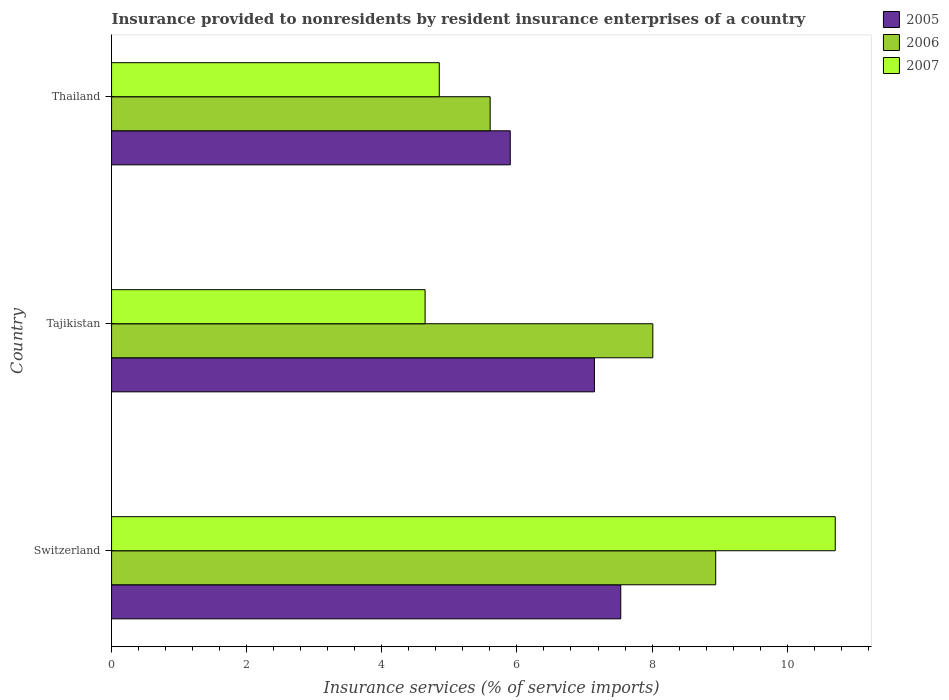Are the number of bars per tick equal to the number of legend labels?
Your answer should be compact. Yes. Are the number of bars on each tick of the Y-axis equal?
Your answer should be compact. Yes. How many bars are there on the 1st tick from the top?
Your answer should be compact. 3. What is the label of the 1st group of bars from the top?
Offer a very short reply. Thailand. What is the insurance provided to nonresidents in 2007 in Switzerland?
Your answer should be compact. 10.71. Across all countries, what is the maximum insurance provided to nonresidents in 2007?
Your answer should be very brief. 10.71. Across all countries, what is the minimum insurance provided to nonresidents in 2005?
Keep it short and to the point. 5.9. In which country was the insurance provided to nonresidents in 2005 maximum?
Your answer should be compact. Switzerland. In which country was the insurance provided to nonresidents in 2007 minimum?
Offer a very short reply. Tajikistan. What is the total insurance provided to nonresidents in 2006 in the graph?
Your answer should be compact. 22.56. What is the difference between the insurance provided to nonresidents in 2005 in Switzerland and that in Tajikistan?
Keep it short and to the point. 0.39. What is the difference between the insurance provided to nonresidents in 2005 in Thailand and the insurance provided to nonresidents in 2006 in Tajikistan?
Your response must be concise. -2.11. What is the average insurance provided to nonresidents in 2005 per country?
Offer a terse response. 6.86. What is the difference between the insurance provided to nonresidents in 2007 and insurance provided to nonresidents in 2006 in Switzerland?
Offer a terse response. 1.77. What is the ratio of the insurance provided to nonresidents in 2006 in Switzerland to that in Tajikistan?
Your answer should be very brief. 1.12. Is the insurance provided to nonresidents in 2005 in Switzerland less than that in Thailand?
Offer a terse response. No. Is the difference between the insurance provided to nonresidents in 2007 in Tajikistan and Thailand greater than the difference between the insurance provided to nonresidents in 2006 in Tajikistan and Thailand?
Provide a short and direct response. No. What is the difference between the highest and the second highest insurance provided to nonresidents in 2007?
Keep it short and to the point. 5.86. What is the difference between the highest and the lowest insurance provided to nonresidents in 2006?
Provide a short and direct response. 3.34. In how many countries, is the insurance provided to nonresidents in 2005 greater than the average insurance provided to nonresidents in 2005 taken over all countries?
Provide a succinct answer. 2. Is it the case that in every country, the sum of the insurance provided to nonresidents in 2005 and insurance provided to nonresidents in 2007 is greater than the insurance provided to nonresidents in 2006?
Your answer should be compact. Yes. Are all the bars in the graph horizontal?
Provide a short and direct response. Yes. How many countries are there in the graph?
Offer a very short reply. 3. Are the values on the major ticks of X-axis written in scientific E-notation?
Your answer should be very brief. No. Does the graph contain grids?
Make the answer very short. No. Where does the legend appear in the graph?
Ensure brevity in your answer.  Top right. How are the legend labels stacked?
Ensure brevity in your answer.  Vertical. What is the title of the graph?
Provide a short and direct response. Insurance provided to nonresidents by resident insurance enterprises of a country. What is the label or title of the X-axis?
Provide a short and direct response. Insurance services (% of service imports). What is the Insurance services (% of service imports) in 2005 in Switzerland?
Your answer should be very brief. 7.54. What is the Insurance services (% of service imports) in 2006 in Switzerland?
Offer a terse response. 8.94. What is the Insurance services (% of service imports) in 2007 in Switzerland?
Ensure brevity in your answer.  10.71. What is the Insurance services (% of service imports) of 2005 in Tajikistan?
Your response must be concise. 7.15. What is the Insurance services (% of service imports) of 2006 in Tajikistan?
Provide a succinct answer. 8.01. What is the Insurance services (% of service imports) of 2007 in Tajikistan?
Offer a terse response. 4.64. What is the Insurance services (% of service imports) in 2005 in Thailand?
Provide a succinct answer. 5.9. What is the Insurance services (% of service imports) of 2006 in Thailand?
Your answer should be very brief. 5.6. What is the Insurance services (% of service imports) in 2007 in Thailand?
Make the answer very short. 4.85. Across all countries, what is the maximum Insurance services (% of service imports) of 2005?
Offer a terse response. 7.54. Across all countries, what is the maximum Insurance services (% of service imports) in 2006?
Your response must be concise. 8.94. Across all countries, what is the maximum Insurance services (% of service imports) in 2007?
Your answer should be compact. 10.71. Across all countries, what is the minimum Insurance services (% of service imports) in 2005?
Ensure brevity in your answer.  5.9. Across all countries, what is the minimum Insurance services (% of service imports) of 2006?
Provide a short and direct response. 5.6. Across all countries, what is the minimum Insurance services (% of service imports) in 2007?
Give a very brief answer. 4.64. What is the total Insurance services (% of service imports) in 2005 in the graph?
Make the answer very short. 20.58. What is the total Insurance services (% of service imports) of 2006 in the graph?
Your answer should be very brief. 22.56. What is the total Insurance services (% of service imports) of 2007 in the graph?
Offer a terse response. 20.2. What is the difference between the Insurance services (% of service imports) of 2005 in Switzerland and that in Tajikistan?
Your answer should be compact. 0.39. What is the difference between the Insurance services (% of service imports) in 2006 in Switzerland and that in Tajikistan?
Offer a very short reply. 0.93. What is the difference between the Insurance services (% of service imports) of 2007 in Switzerland and that in Tajikistan?
Provide a succinct answer. 6.07. What is the difference between the Insurance services (% of service imports) of 2005 in Switzerland and that in Thailand?
Offer a terse response. 1.64. What is the difference between the Insurance services (% of service imports) of 2006 in Switzerland and that in Thailand?
Your answer should be very brief. 3.34. What is the difference between the Insurance services (% of service imports) of 2007 in Switzerland and that in Thailand?
Offer a very short reply. 5.86. What is the difference between the Insurance services (% of service imports) in 2005 in Tajikistan and that in Thailand?
Provide a succinct answer. 1.25. What is the difference between the Insurance services (% of service imports) in 2006 in Tajikistan and that in Thailand?
Offer a terse response. 2.41. What is the difference between the Insurance services (% of service imports) in 2007 in Tajikistan and that in Thailand?
Offer a very short reply. -0.21. What is the difference between the Insurance services (% of service imports) in 2005 in Switzerland and the Insurance services (% of service imports) in 2006 in Tajikistan?
Offer a terse response. -0.47. What is the difference between the Insurance services (% of service imports) in 2005 in Switzerland and the Insurance services (% of service imports) in 2007 in Tajikistan?
Your response must be concise. 2.9. What is the difference between the Insurance services (% of service imports) of 2006 in Switzerland and the Insurance services (% of service imports) of 2007 in Tajikistan?
Give a very brief answer. 4.3. What is the difference between the Insurance services (% of service imports) of 2005 in Switzerland and the Insurance services (% of service imports) of 2006 in Thailand?
Keep it short and to the point. 1.93. What is the difference between the Insurance services (% of service imports) of 2005 in Switzerland and the Insurance services (% of service imports) of 2007 in Thailand?
Your answer should be compact. 2.69. What is the difference between the Insurance services (% of service imports) in 2006 in Switzerland and the Insurance services (% of service imports) in 2007 in Thailand?
Give a very brief answer. 4.09. What is the difference between the Insurance services (% of service imports) of 2005 in Tajikistan and the Insurance services (% of service imports) of 2006 in Thailand?
Offer a terse response. 1.54. What is the difference between the Insurance services (% of service imports) in 2005 in Tajikistan and the Insurance services (% of service imports) in 2007 in Thailand?
Provide a succinct answer. 2.3. What is the difference between the Insurance services (% of service imports) in 2006 in Tajikistan and the Insurance services (% of service imports) in 2007 in Thailand?
Your response must be concise. 3.16. What is the average Insurance services (% of service imports) of 2005 per country?
Your answer should be compact. 6.86. What is the average Insurance services (% of service imports) in 2006 per country?
Offer a terse response. 7.52. What is the average Insurance services (% of service imports) of 2007 per country?
Give a very brief answer. 6.73. What is the difference between the Insurance services (% of service imports) in 2005 and Insurance services (% of service imports) in 2006 in Switzerland?
Ensure brevity in your answer.  -1.41. What is the difference between the Insurance services (% of service imports) in 2005 and Insurance services (% of service imports) in 2007 in Switzerland?
Give a very brief answer. -3.17. What is the difference between the Insurance services (% of service imports) of 2006 and Insurance services (% of service imports) of 2007 in Switzerland?
Your response must be concise. -1.77. What is the difference between the Insurance services (% of service imports) in 2005 and Insurance services (% of service imports) in 2006 in Tajikistan?
Offer a very short reply. -0.86. What is the difference between the Insurance services (% of service imports) of 2005 and Insurance services (% of service imports) of 2007 in Tajikistan?
Provide a succinct answer. 2.51. What is the difference between the Insurance services (% of service imports) in 2006 and Insurance services (% of service imports) in 2007 in Tajikistan?
Your answer should be compact. 3.37. What is the difference between the Insurance services (% of service imports) of 2005 and Insurance services (% of service imports) of 2006 in Thailand?
Offer a terse response. 0.3. What is the difference between the Insurance services (% of service imports) in 2005 and Insurance services (% of service imports) in 2007 in Thailand?
Offer a terse response. 1.05. What is the difference between the Insurance services (% of service imports) of 2006 and Insurance services (% of service imports) of 2007 in Thailand?
Offer a terse response. 0.75. What is the ratio of the Insurance services (% of service imports) in 2005 in Switzerland to that in Tajikistan?
Your answer should be compact. 1.05. What is the ratio of the Insurance services (% of service imports) in 2006 in Switzerland to that in Tajikistan?
Your response must be concise. 1.12. What is the ratio of the Insurance services (% of service imports) of 2007 in Switzerland to that in Tajikistan?
Your answer should be compact. 2.31. What is the ratio of the Insurance services (% of service imports) of 2005 in Switzerland to that in Thailand?
Your answer should be very brief. 1.28. What is the ratio of the Insurance services (% of service imports) in 2006 in Switzerland to that in Thailand?
Provide a succinct answer. 1.6. What is the ratio of the Insurance services (% of service imports) in 2007 in Switzerland to that in Thailand?
Give a very brief answer. 2.21. What is the ratio of the Insurance services (% of service imports) of 2005 in Tajikistan to that in Thailand?
Keep it short and to the point. 1.21. What is the ratio of the Insurance services (% of service imports) of 2006 in Tajikistan to that in Thailand?
Provide a short and direct response. 1.43. What is the ratio of the Insurance services (% of service imports) of 2007 in Tajikistan to that in Thailand?
Provide a short and direct response. 0.96. What is the difference between the highest and the second highest Insurance services (% of service imports) in 2005?
Your answer should be compact. 0.39. What is the difference between the highest and the second highest Insurance services (% of service imports) of 2006?
Make the answer very short. 0.93. What is the difference between the highest and the second highest Insurance services (% of service imports) of 2007?
Offer a very short reply. 5.86. What is the difference between the highest and the lowest Insurance services (% of service imports) of 2005?
Offer a terse response. 1.64. What is the difference between the highest and the lowest Insurance services (% of service imports) of 2006?
Offer a terse response. 3.34. What is the difference between the highest and the lowest Insurance services (% of service imports) of 2007?
Ensure brevity in your answer.  6.07. 